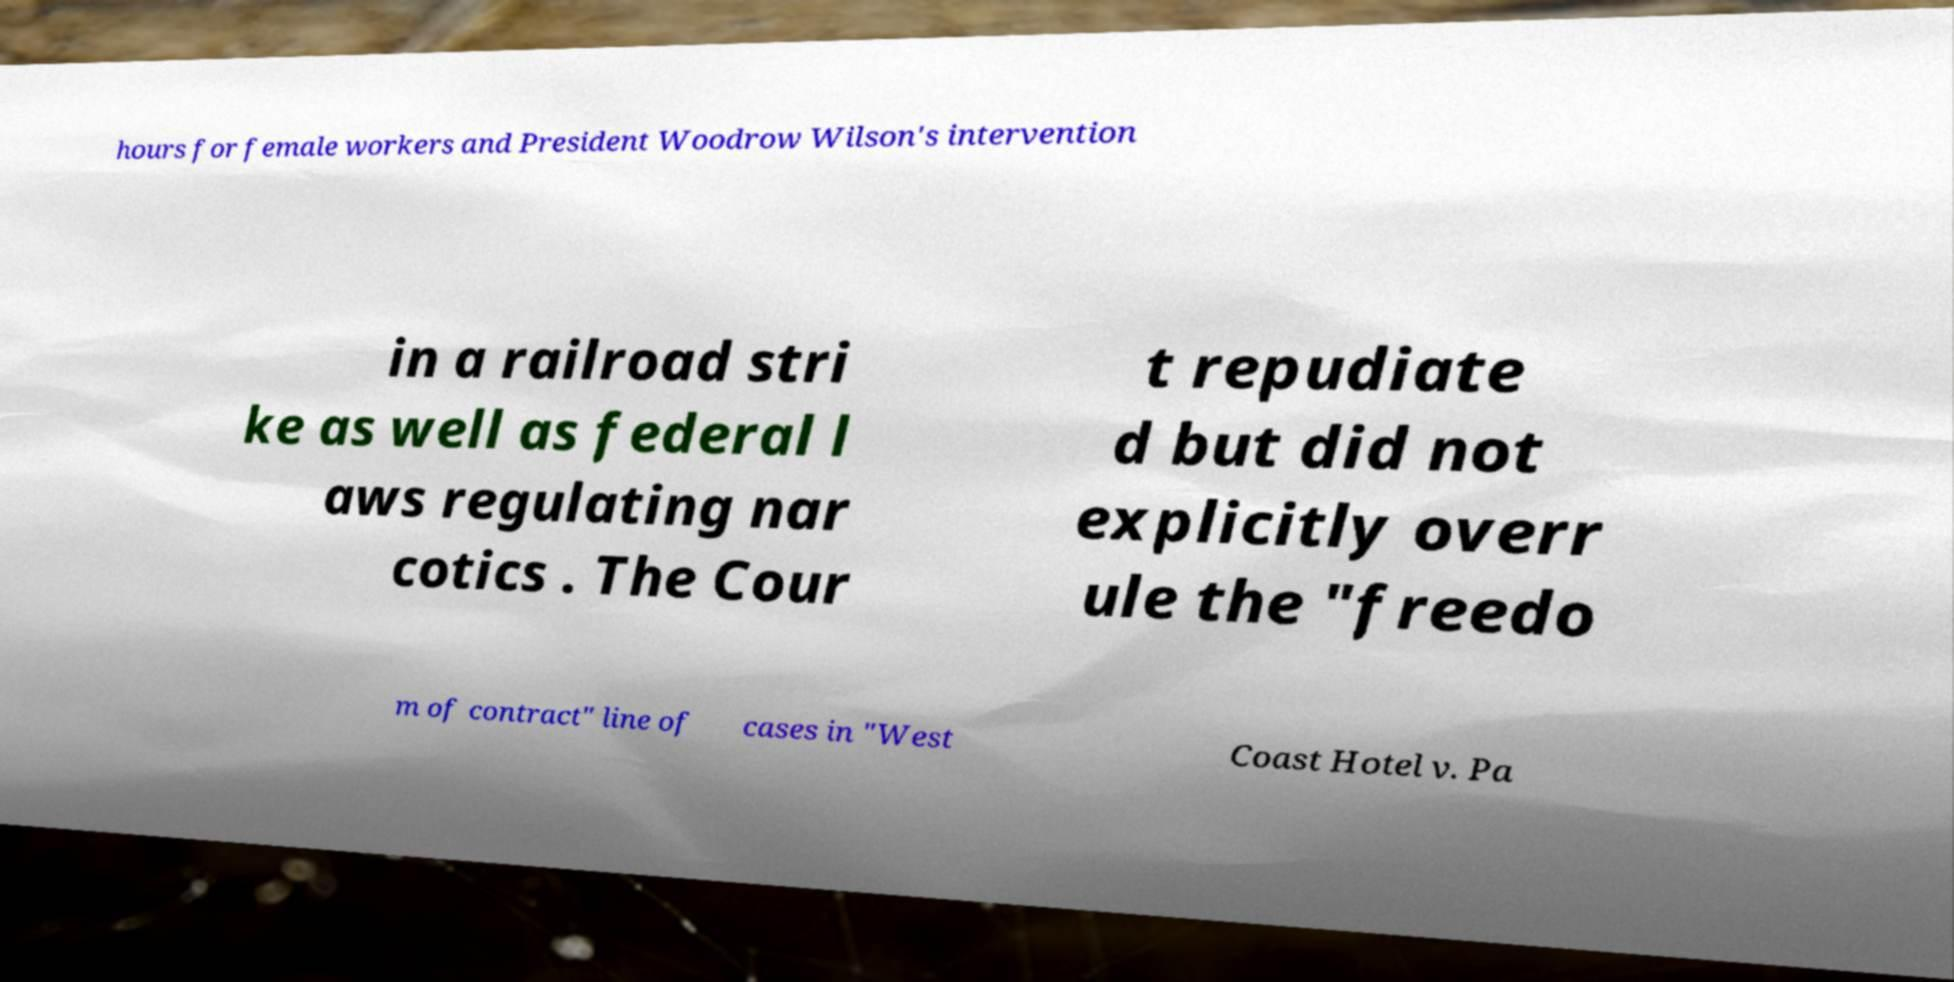For documentation purposes, I need the text within this image transcribed. Could you provide that? hours for female workers and President Woodrow Wilson's intervention in a railroad stri ke as well as federal l aws regulating nar cotics . The Cour t repudiate d but did not explicitly overr ule the "freedo m of contract" line of cases in "West Coast Hotel v. Pa 